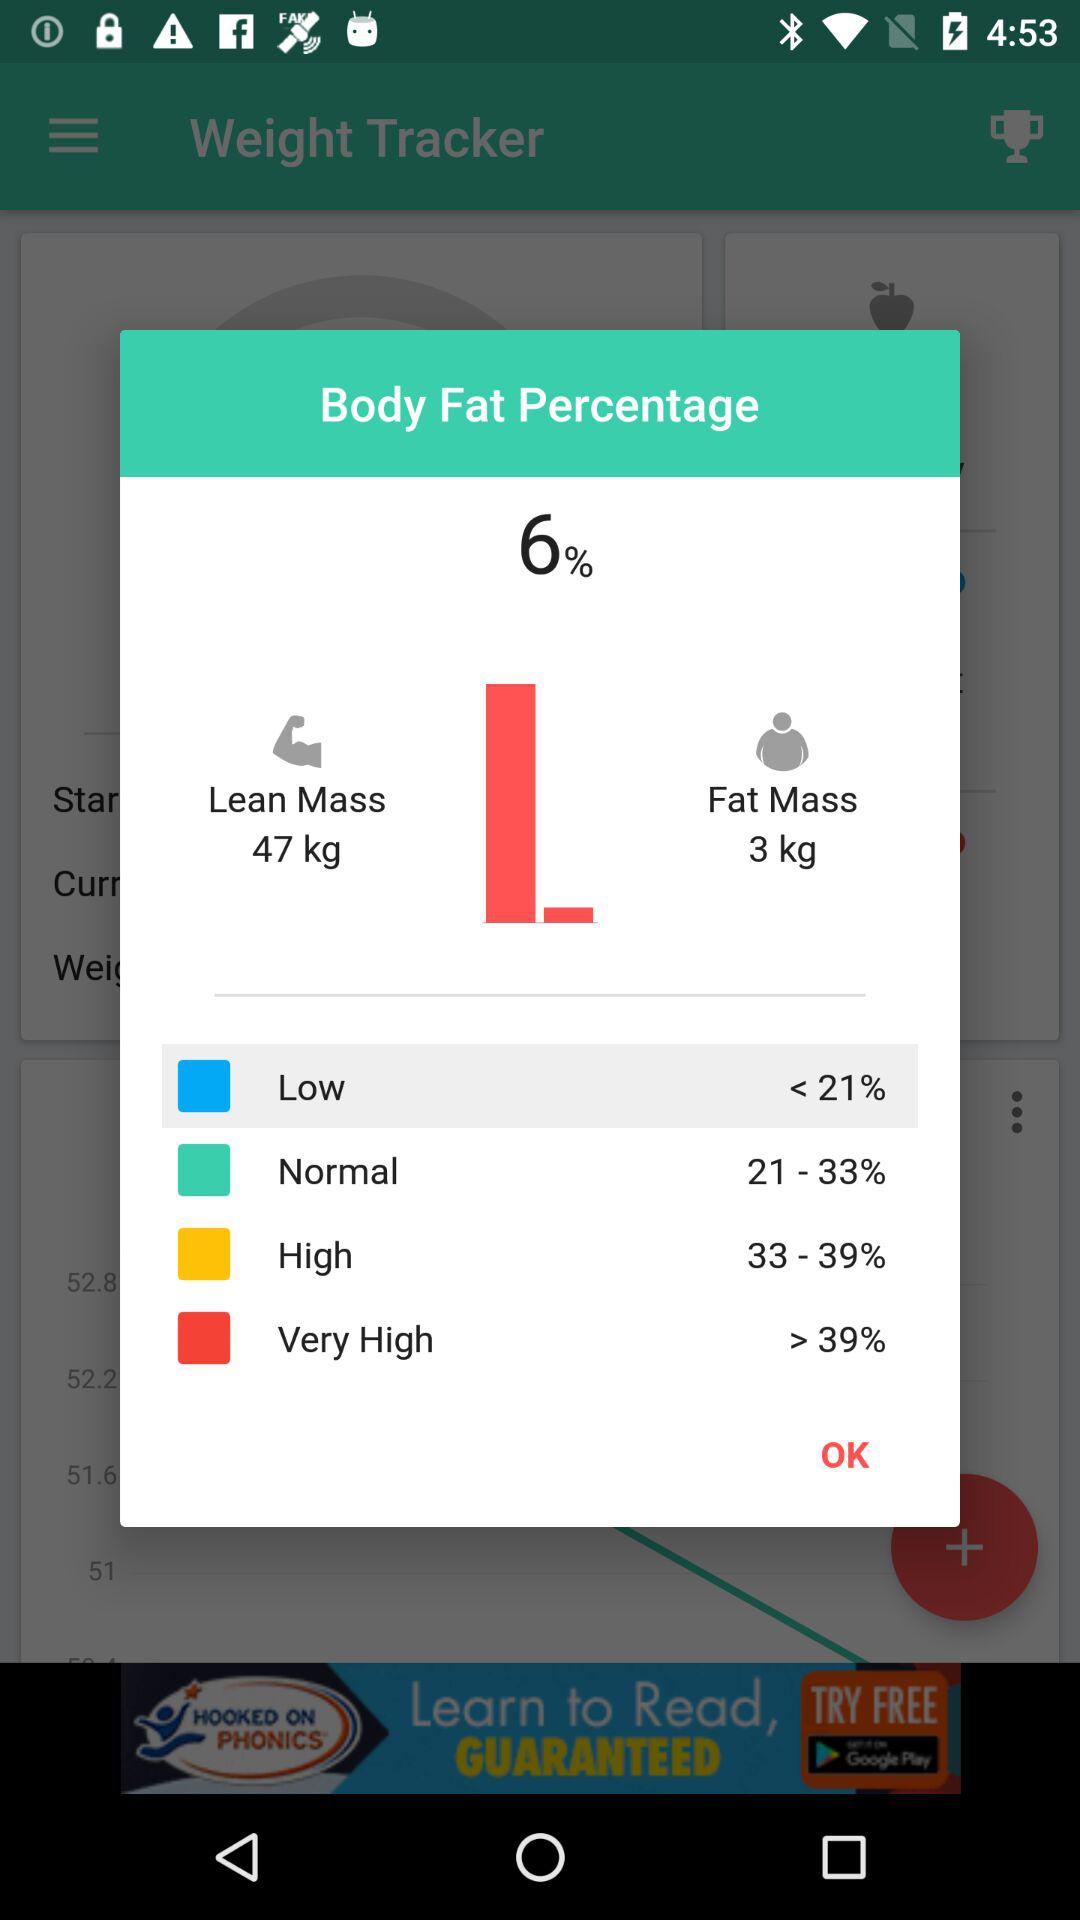What is the low percentage of body fat? The low percentage of body fat is less than 21. 